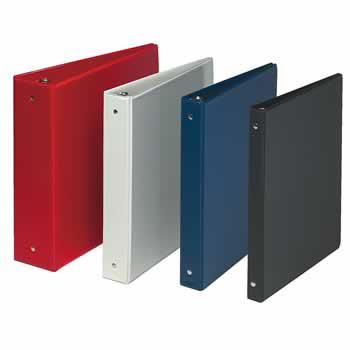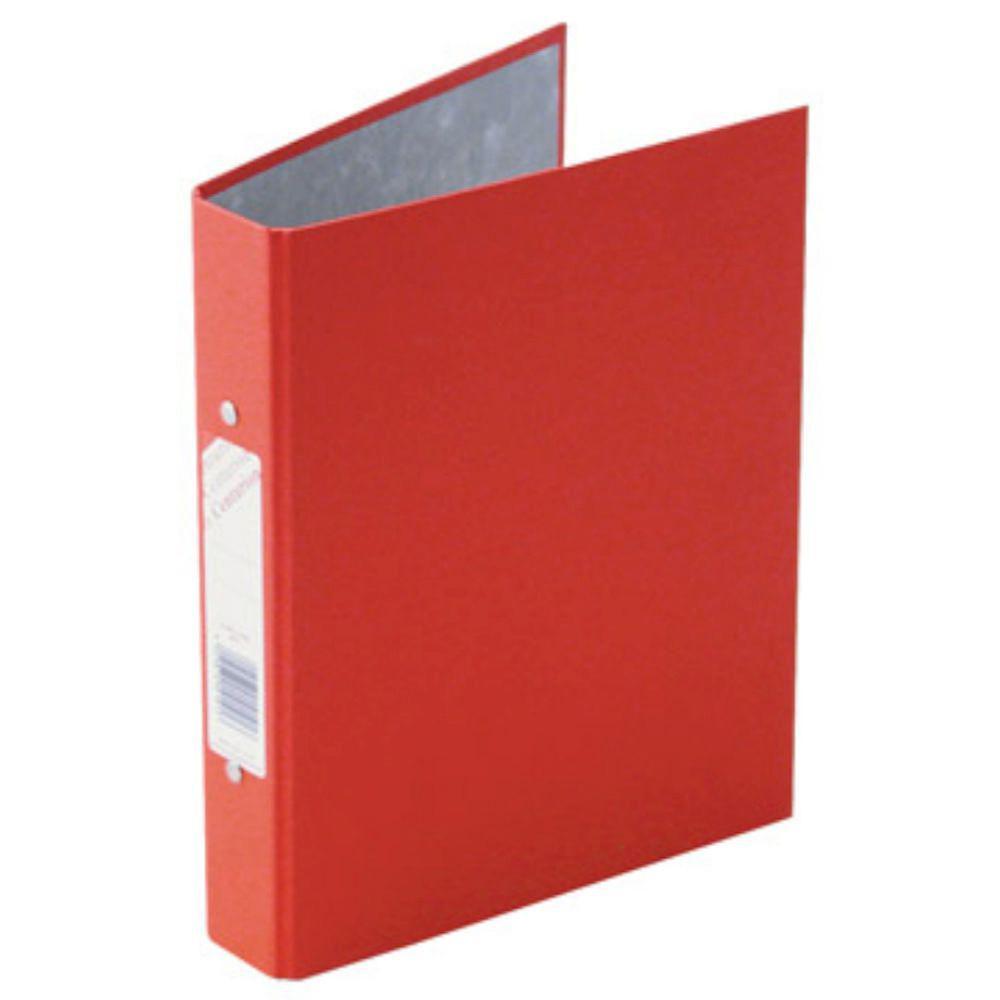The first image is the image on the left, the second image is the image on the right. For the images shown, is this caption "Five note books, all in different colors, are shown, four in one image all facing the same way, and one in the other image that has a white label on the spine." true? Answer yes or no. Yes. The first image is the image on the left, the second image is the image on the right. Evaluate the accuracy of this statement regarding the images: "One image shows four upright binders of different colors, and the other shows just one upright binder.". Is it true? Answer yes or no. Yes. 